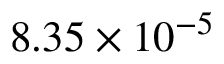Convert formula to latex. <formula><loc_0><loc_0><loc_500><loc_500>8 . 3 5 \times 1 0 ^ { - 5 }</formula> 